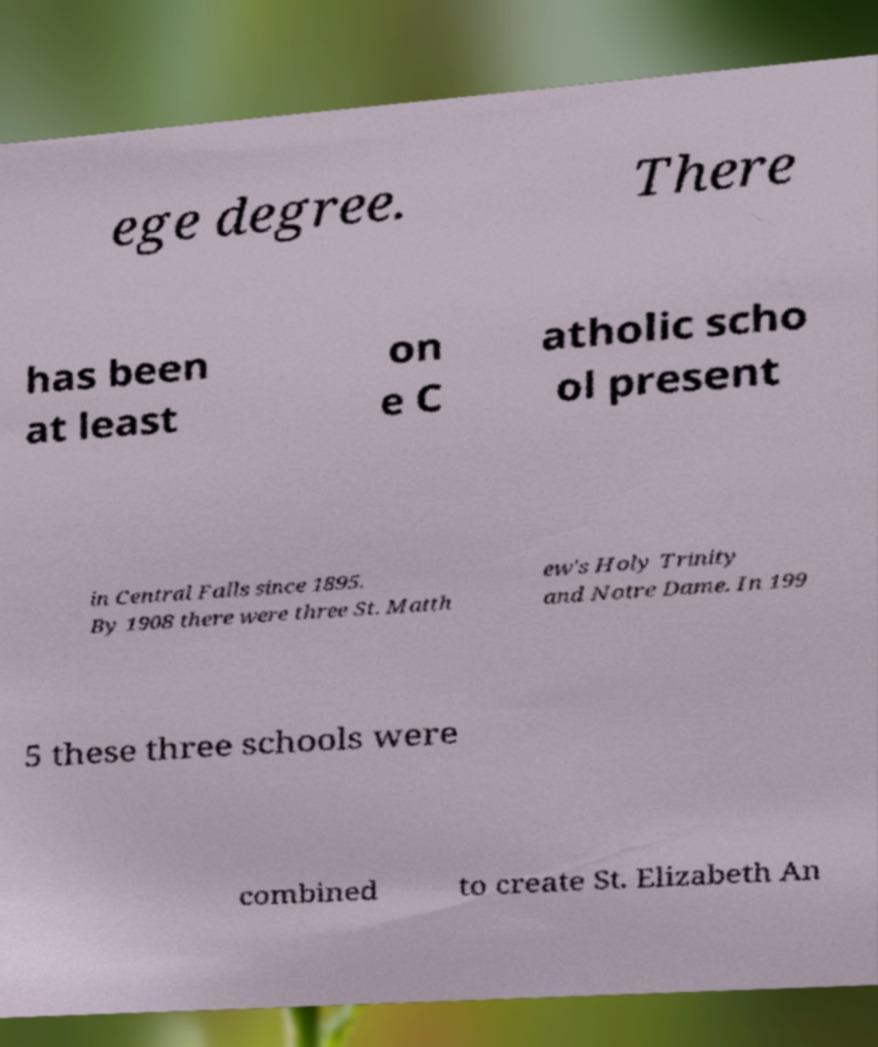Could you extract and type out the text from this image? ege degree. There has been at least on e C atholic scho ol present in Central Falls since 1895. By 1908 there were three St. Matth ew's Holy Trinity and Notre Dame. In 199 5 these three schools were combined to create St. Elizabeth An 